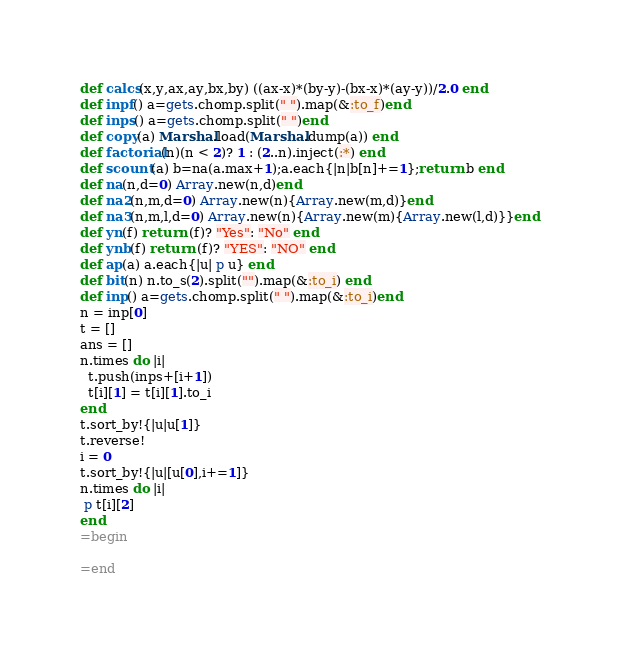Convert code to text. <code><loc_0><loc_0><loc_500><loc_500><_Ruby_>def calcs(x,y,ax,ay,bx,by) ((ax-x)*(by-y)-(bx-x)*(ay-y))/2.0 end
def inpf() a=gets.chomp.split(" ").map(&:to_f)end
def inps() a=gets.chomp.split(" ")end  
def copy(a) Marshal.load(Marshal.dump(a)) end
def factorial(n)(n < 2)? 1 : (2..n).inject(:*) end
def scount(a) b=na(a.max+1);a.each{|n|b[n]+=1};return b end
def na(n,d=0) Array.new(n,d)end
def na2(n,m,d=0) Array.new(n){Array.new(m,d)}end
def na3(n,m,l,d=0) Array.new(n){Array.new(m){Array.new(l,d)}}end
def yn(f) return (f)? "Yes": "No" end
def ynb(f) return (f)? "YES": "NO" end
def ap(a) a.each{|u| p u} end
def bit(n) n.to_s(2).split("").map(&:to_i) end
def inp() a=gets.chomp.split(" ").map(&:to_i)end
n = inp[0]
t = []
ans = []
n.times do |i|
  t.push(inps+[i+1])
  t[i][1] = t[i][1].to_i
end
t.sort_by!{|u|u[1]}
t.reverse!
i = 0
t.sort_by!{|u|[u[0],i+=1]}
n.times do |i|
 p t[i][2]
end
=begin

=end</code> 